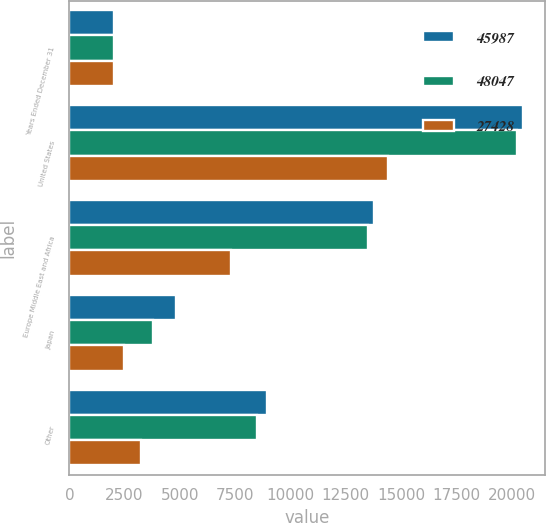<chart> <loc_0><loc_0><loc_500><loc_500><stacked_bar_chart><ecel><fcel>Years Ended December 31<fcel>United States<fcel>Europe Middle East and Africa<fcel>Japan<fcel>Other<nl><fcel>45987<fcel>2011<fcel>20495<fcel>13782<fcel>4835<fcel>8935<nl><fcel>48047<fcel>2010<fcel>20226<fcel>13497<fcel>3768<fcel>8496<nl><fcel>27428<fcel>2009<fcel>14401<fcel>7326<fcel>2452<fcel>3249<nl></chart> 